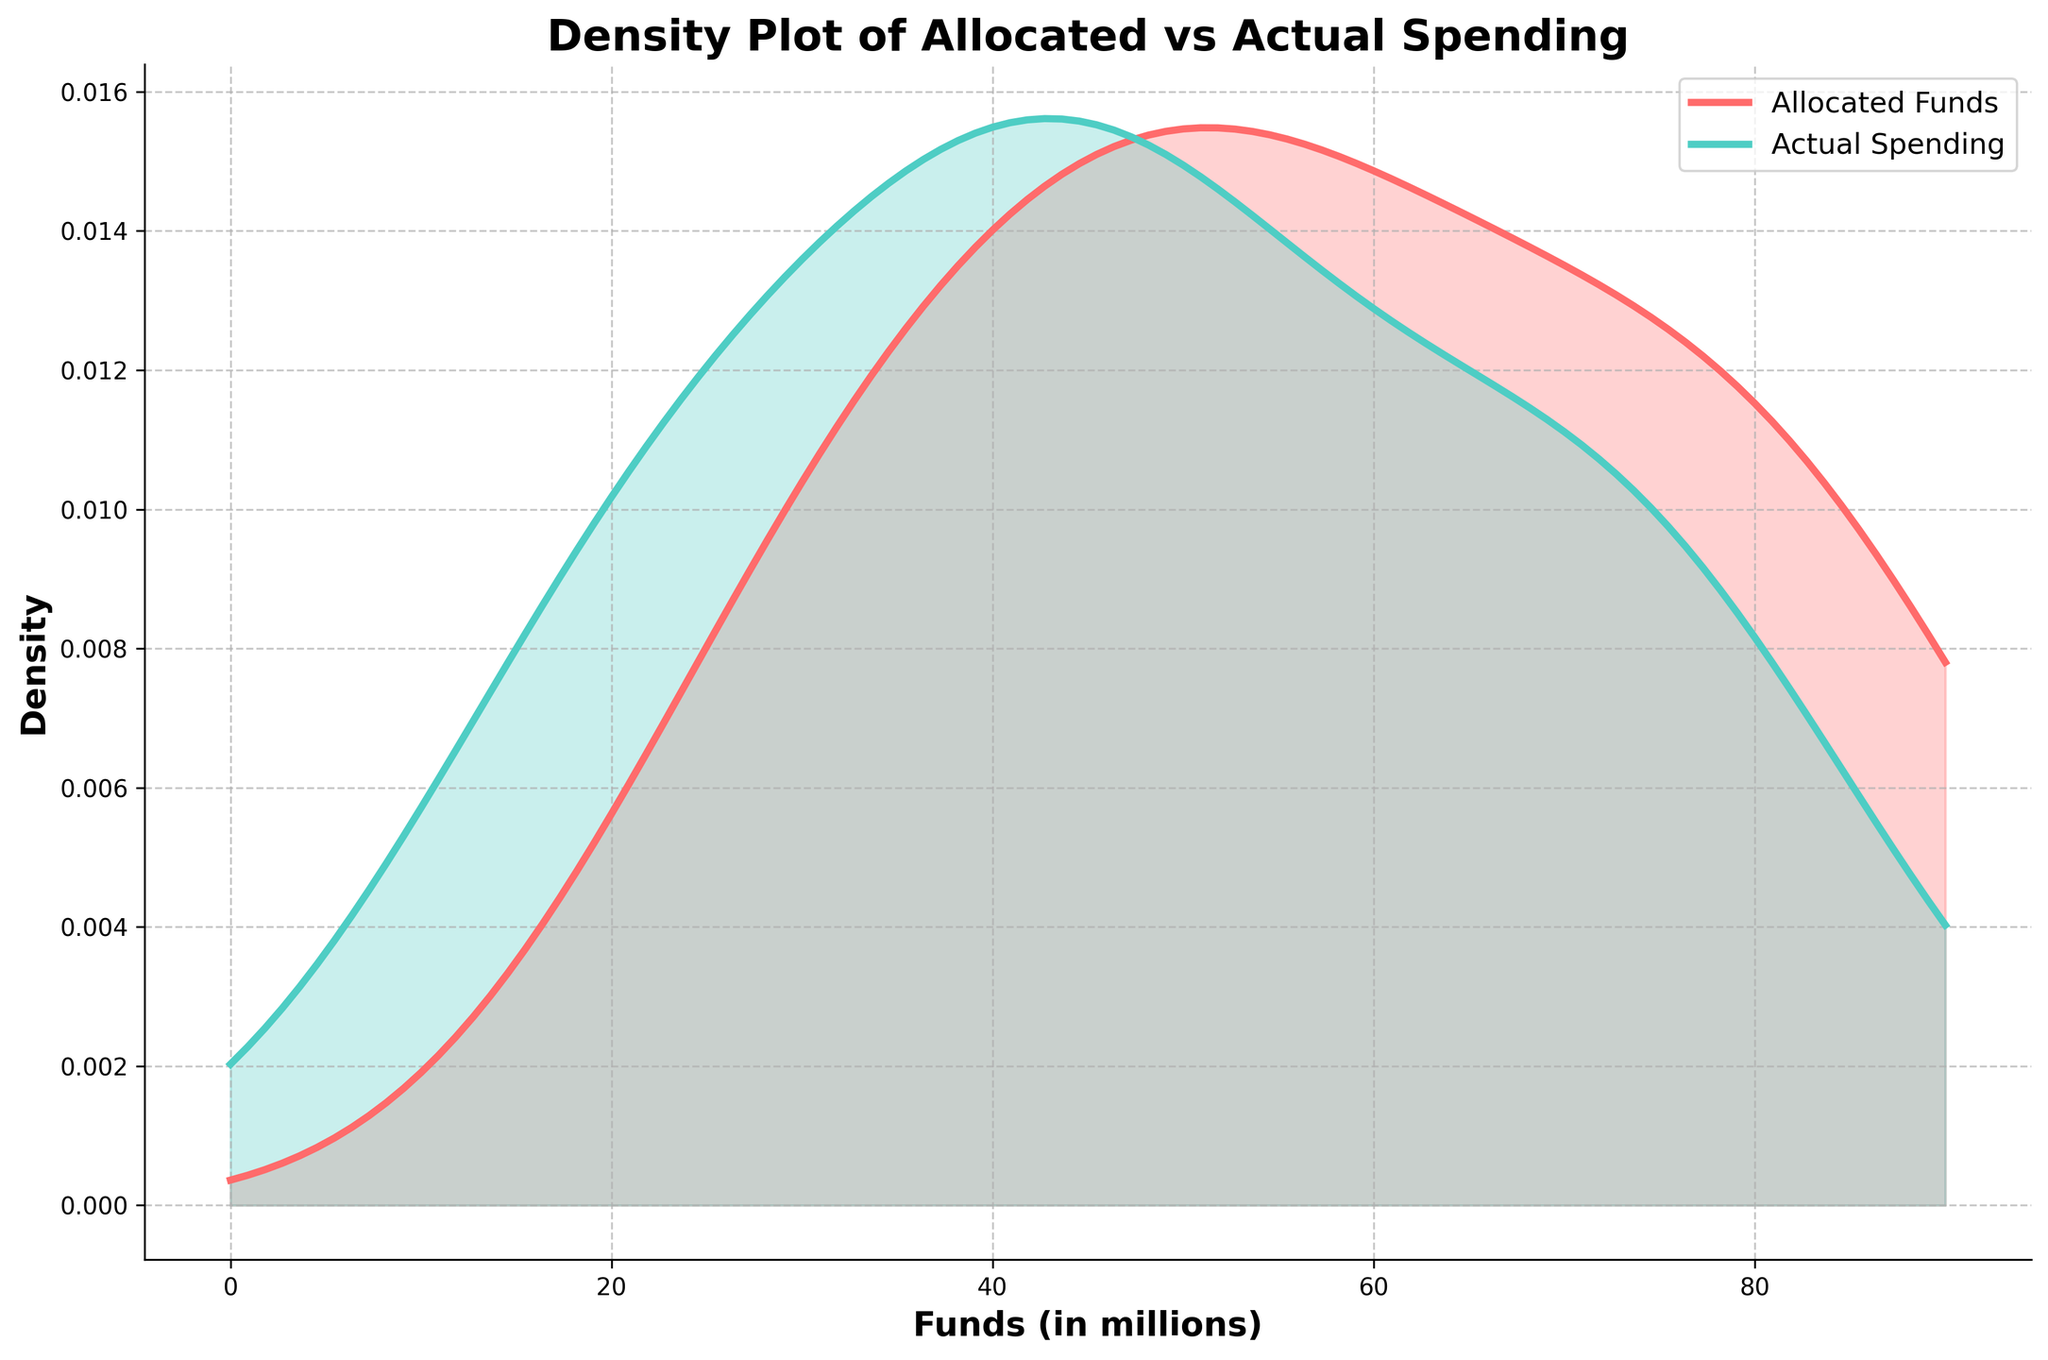What is the title of the figure? The title is usually displayed at the top of the figure. In this case, the title is "Density Plot of Allocated vs Actual Spending."
Answer: Density Plot of Allocated vs Actual Spending What are the colors used for the allocated funds and actual spending lines? The allocated funds density line is represented in a reddish color, and the actual spending density line is represented in a teal color.
Answer: Allocated funds: reddish, Actual spending: teal What is the maximum value on the funds (in millions) axis? The x-axis, which represents funds in millions, has an upper limit determined by the highest values in the data. Based on the x_range, this maximum appears to be around 100 million.
Answer: 100 million Which curve has the higher density at around 50 million funds - allocated or actual spending? By observing the plots, you can see that the allocated funds' density is higher than the actual spending's density around the 50 million marks.
Answer: Allocated funds At what approximate fund value do the density plots of allocated funds and actual spending converge? The KDE curves for both allocated funds and actual spending come close to converging around the 70 million mark.
Answer: Around 70 million Which category shows a significant deviation between allocated funds and actual spending by looking at the density plots? To identify significant deviations, compare the densities of allocated funds and actual spending. Deviation is evident where the two curves have the largest gaps, and this seems to happen around the 35 million and 70 million marks. This could correspond to Research and Development and Procurement categories.
Answer: Research and Development, Procurement During which fund ranges do both allocated funds and actual spending have their peaks? Examining the density plot, the peaks for allocated funds and actual spending are in the lower fund ranges around 20 to 35 million for actual spending and closer to 70 million for allocated funds.
Answer: Allocated funds: around 70 million, Actual spending: around 30 million Which type of funds shows a more evenly distributed spending pattern across the range of fund values? Observing the density curves, the allocated funds curve shows a more uniform distribution across fund values, while the actual spending curve shows more peaks and troughs, indicating variability in spending patterns.
Answer: Allocated funds How do the density curves illustrate the potential for misappropriation? Density plots highlight discrepancies between allocated and actual spending. The large deviations at certain fund values may indicate areas of significant underspending or potential misappropriation.
Answer: Large deviations indicate misappropriation potential Is there symmetry about the fund values in the density plots for either allocated funds or actual spending? The density plot for allocated funds is relatively symmetric, especially around the high fund values, while the actual spending curve is more asymmetric, showing significant variation at certain points.
Answer: Allocated funds: relatively symmetric, Actual spending: asymmetric 